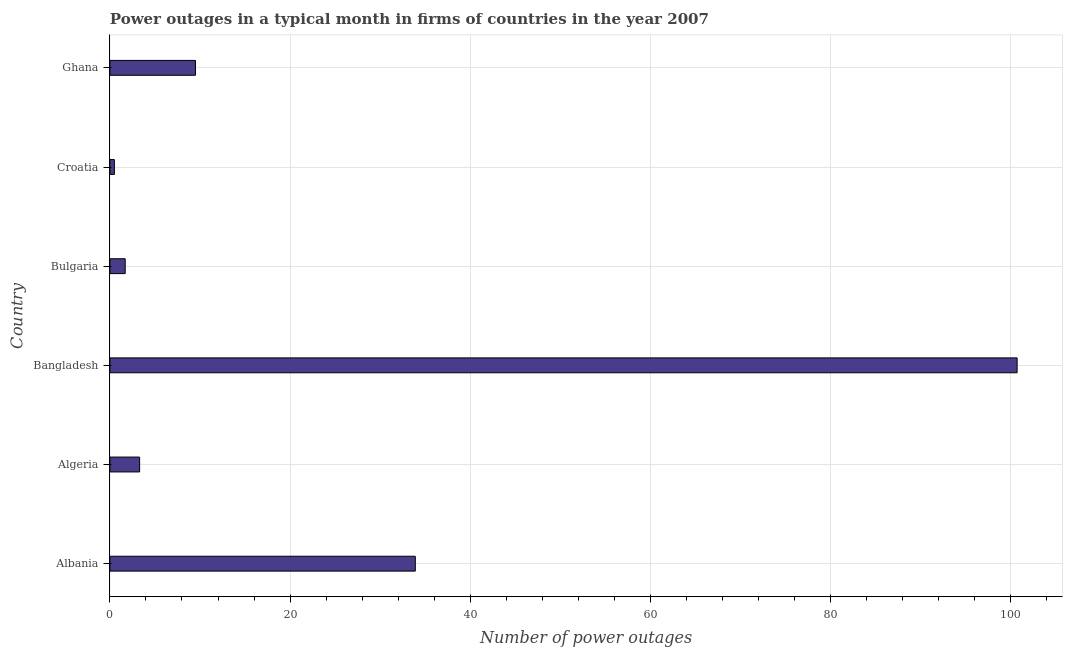Does the graph contain any zero values?
Give a very brief answer. No. Does the graph contain grids?
Your response must be concise. Yes. What is the title of the graph?
Make the answer very short. Power outages in a typical month in firms of countries in the year 2007. What is the label or title of the X-axis?
Keep it short and to the point. Number of power outages. What is the label or title of the Y-axis?
Make the answer very short. Country. What is the number of power outages in Albania?
Provide a succinct answer. 33.9. Across all countries, what is the maximum number of power outages?
Offer a terse response. 100.7. Across all countries, what is the minimum number of power outages?
Provide a short and direct response. 0.5. In which country was the number of power outages maximum?
Offer a terse response. Bangladesh. In which country was the number of power outages minimum?
Ensure brevity in your answer.  Croatia. What is the sum of the number of power outages?
Provide a short and direct response. 149.6. What is the difference between the number of power outages in Algeria and Croatia?
Offer a terse response. 2.8. What is the average number of power outages per country?
Your answer should be compact. 24.93. In how many countries, is the number of power outages greater than 20 ?
Provide a succinct answer. 2. What is the ratio of the number of power outages in Albania to that in Croatia?
Keep it short and to the point. 67.8. Is the number of power outages in Albania less than that in Algeria?
Ensure brevity in your answer.  No. What is the difference between the highest and the second highest number of power outages?
Offer a very short reply. 66.8. What is the difference between the highest and the lowest number of power outages?
Ensure brevity in your answer.  100.2. In how many countries, is the number of power outages greater than the average number of power outages taken over all countries?
Make the answer very short. 2. How many bars are there?
Your answer should be very brief. 6. Are all the bars in the graph horizontal?
Offer a terse response. Yes. How many countries are there in the graph?
Your answer should be very brief. 6. What is the difference between two consecutive major ticks on the X-axis?
Your response must be concise. 20. What is the Number of power outages in Albania?
Offer a very short reply. 33.9. What is the Number of power outages of Bangladesh?
Provide a succinct answer. 100.7. What is the Number of power outages in Croatia?
Make the answer very short. 0.5. What is the difference between the Number of power outages in Albania and Algeria?
Ensure brevity in your answer.  30.6. What is the difference between the Number of power outages in Albania and Bangladesh?
Your answer should be compact. -66.8. What is the difference between the Number of power outages in Albania and Bulgaria?
Your answer should be very brief. 32.2. What is the difference between the Number of power outages in Albania and Croatia?
Provide a succinct answer. 33.4. What is the difference between the Number of power outages in Albania and Ghana?
Your answer should be compact. 24.4. What is the difference between the Number of power outages in Algeria and Bangladesh?
Ensure brevity in your answer.  -97.4. What is the difference between the Number of power outages in Algeria and Ghana?
Provide a short and direct response. -6.2. What is the difference between the Number of power outages in Bangladesh and Croatia?
Provide a succinct answer. 100.2. What is the difference between the Number of power outages in Bangladesh and Ghana?
Your answer should be compact. 91.2. What is the difference between the Number of power outages in Bulgaria and Ghana?
Offer a terse response. -7.8. What is the difference between the Number of power outages in Croatia and Ghana?
Keep it short and to the point. -9. What is the ratio of the Number of power outages in Albania to that in Algeria?
Keep it short and to the point. 10.27. What is the ratio of the Number of power outages in Albania to that in Bangladesh?
Provide a succinct answer. 0.34. What is the ratio of the Number of power outages in Albania to that in Bulgaria?
Your answer should be compact. 19.94. What is the ratio of the Number of power outages in Albania to that in Croatia?
Ensure brevity in your answer.  67.8. What is the ratio of the Number of power outages in Albania to that in Ghana?
Give a very brief answer. 3.57. What is the ratio of the Number of power outages in Algeria to that in Bangladesh?
Ensure brevity in your answer.  0.03. What is the ratio of the Number of power outages in Algeria to that in Bulgaria?
Your response must be concise. 1.94. What is the ratio of the Number of power outages in Algeria to that in Croatia?
Your response must be concise. 6.6. What is the ratio of the Number of power outages in Algeria to that in Ghana?
Make the answer very short. 0.35. What is the ratio of the Number of power outages in Bangladesh to that in Bulgaria?
Your answer should be very brief. 59.23. What is the ratio of the Number of power outages in Bangladesh to that in Croatia?
Provide a succinct answer. 201.4. What is the ratio of the Number of power outages in Bangladesh to that in Ghana?
Your answer should be very brief. 10.6. What is the ratio of the Number of power outages in Bulgaria to that in Ghana?
Keep it short and to the point. 0.18. What is the ratio of the Number of power outages in Croatia to that in Ghana?
Your answer should be very brief. 0.05. 